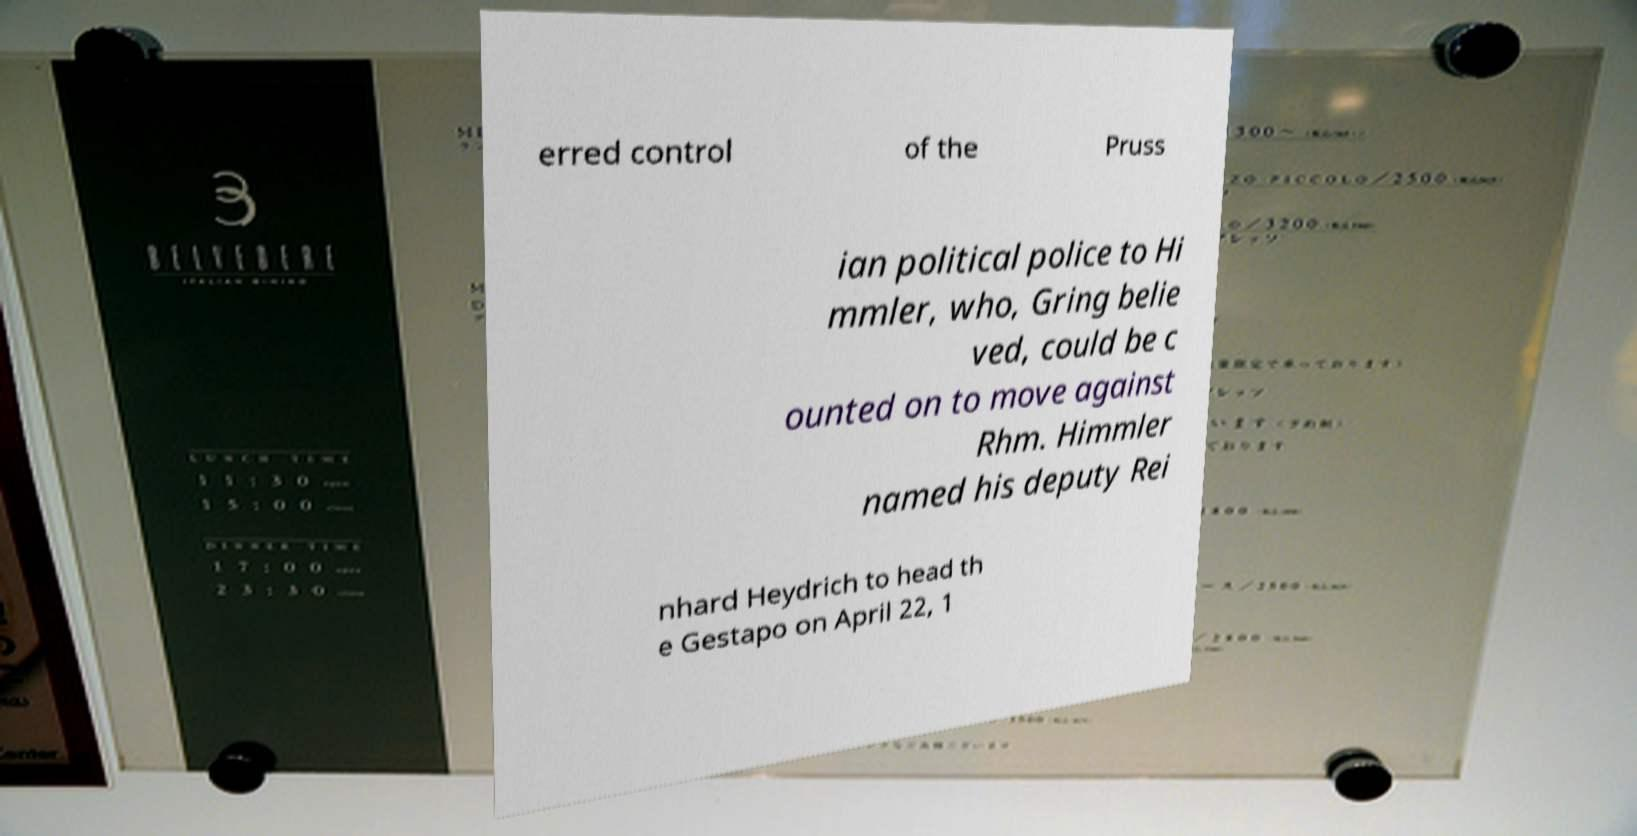What messages or text are displayed in this image? I need them in a readable, typed format. erred control of the Pruss ian political police to Hi mmler, who, Gring belie ved, could be c ounted on to move against Rhm. Himmler named his deputy Rei nhard Heydrich to head th e Gestapo on April 22, 1 